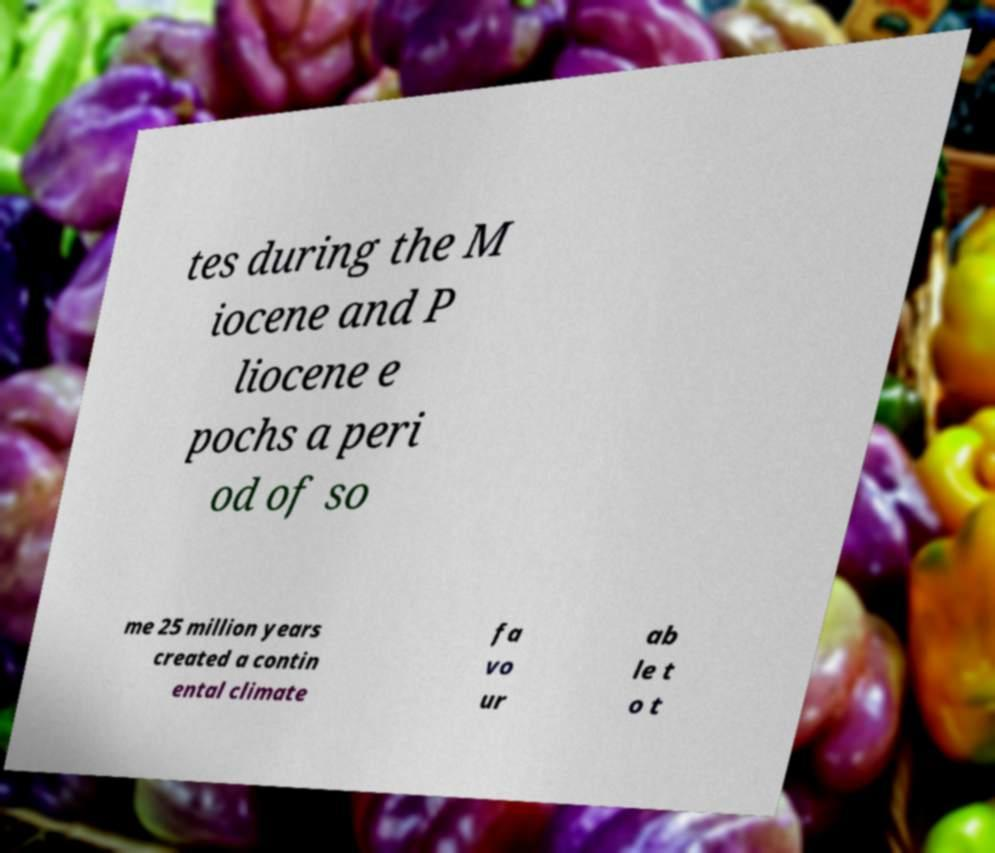Could you extract and type out the text from this image? tes during the M iocene and P liocene e pochs a peri od of so me 25 million years created a contin ental climate fa vo ur ab le t o t 